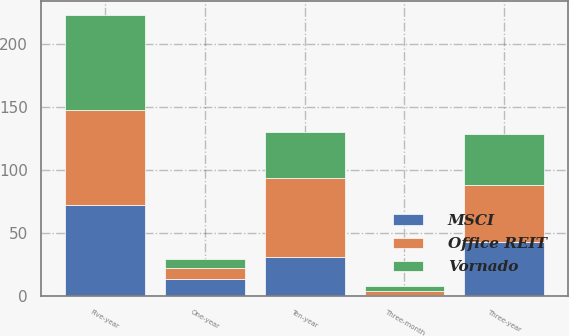Convert chart to OTSL. <chart><loc_0><loc_0><loc_500><loc_500><stacked_bar_chart><ecel><fcel>Three-month<fcel>One-year<fcel>Three-year<fcel>Five-year<fcel>Ten-year<nl><fcel>Vornado<fcel>3.9<fcel>7.3<fcel>40.6<fcel>76<fcel>36.9<nl><fcel>MSCI<fcel>0.6<fcel>13.2<fcel>42.8<fcel>72.1<fcel>31<nl><fcel>Office REIT<fcel>3<fcel>8.6<fcel>45.2<fcel>75.2<fcel>62.3<nl></chart> 